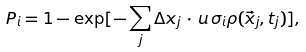<formula> <loc_0><loc_0><loc_500><loc_500>P _ { i } = 1 - \exp [ - \sum _ { j } \Delta x _ { j } \, \cdot \, u \, \sigma _ { i } \rho ( \vec { x } _ { j } , t _ { j } ) ] ,</formula> 